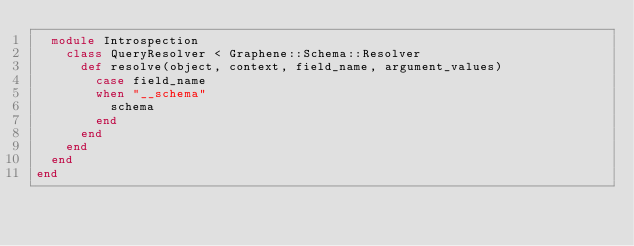Convert code to text. <code><loc_0><loc_0><loc_500><loc_500><_Crystal_>  module Introspection
    class QueryResolver < Graphene::Schema::Resolver
      def resolve(object, context, field_name, argument_values)
        case field_name
        when "__schema"
          schema
        end
      end
    end
  end
end</code> 